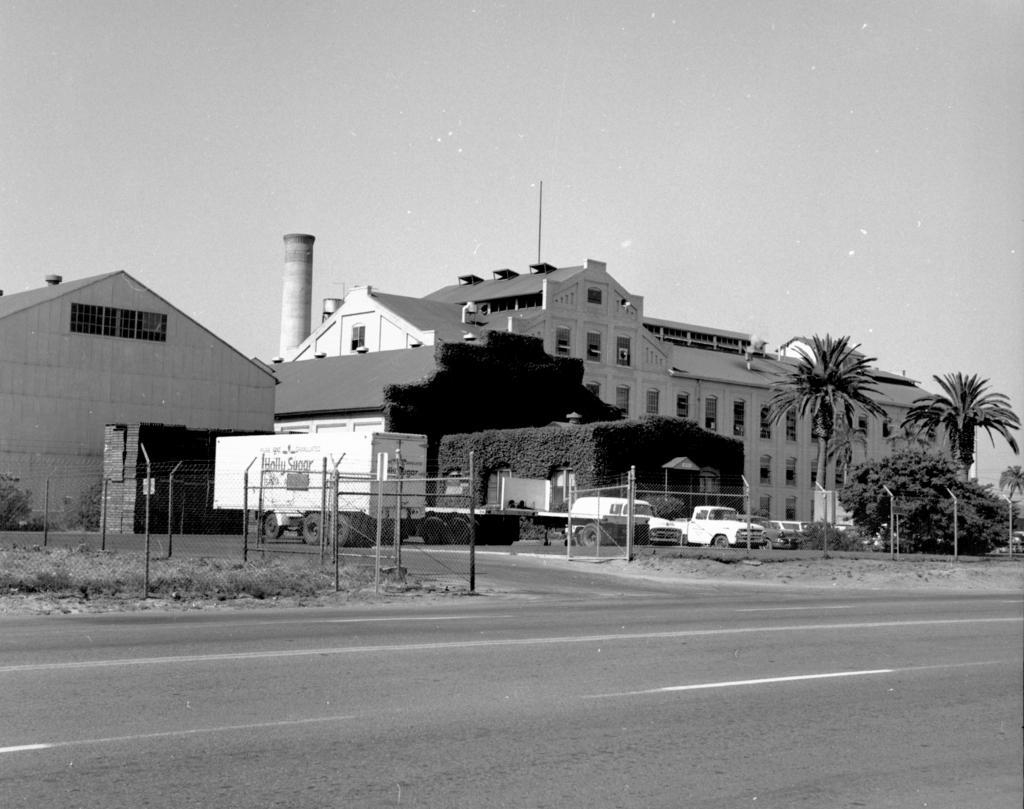What is the color scheme of the image? The image is black and white. What type of structures can be seen in the image? There are buildings in the image. What else is present in the image besides buildings? There are vehicles, trees, plants, a fence, objects on the ground, and the sky visible in the image. How many fish can be seen swimming in the image? There are no fish present in the image; it is a black and white image featuring buildings, vehicles, trees, plants, a fence, objects on the ground, and the sky. What does the image need to be considered complete? The image is already complete as it is, and there is no need for additional elements to make it complete. 